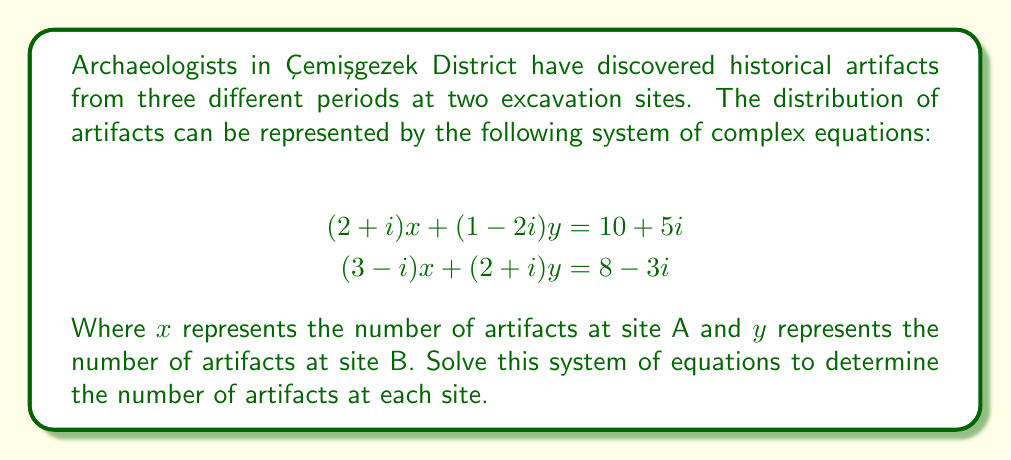Show me your answer to this math problem. To solve this system of equations with complex coefficients, we'll use the substitution method:

1) From the first equation, express $x$ in terms of $y$:
   $$(2+i)x + (1-2i)y = 10+5i$$
   $$(2+i)x = (10+5i) - (1-2i)y$$
   $$x = \frac{(10+5i) - (1-2i)y}{2+i}$$

2) Multiply both numerator and denominator by the complex conjugate of the denominator:
   $$x = \frac{((10+5i) - (1-2i)y)(2-i)}{(2+i)(2-i)}$$
   $$x = \frac{(10+5i)(2-i) - (1-2i)(2-i)y}{5}$$

3) Expand:
   $$x = \frac{(20-10i+10i+5i^2) - (2-i-4i+2i^2)y}{5}$$
   $$x = \frac{(15-5) - (2+3i)y}{5} = 2 - \frac{2+3i}{5}y$$

4) Substitute this expression for $x$ into the second equation:
   $$(3-i)(2 - \frac{2+3i}{5}y) + (2+i)y = 8-3i$$

5) Expand:
   $$(6-2i) - \frac{6+9i-2i-3i^2}{5}y + (2+i)y = 8-3i$$
   $$(6-2i) - \frac{9+7i}{5}y + (2+i)y = 8-3i$$

6) Multiply all terms by 5:
   $$(30-10i) - (9+7i)y + (10+5i)y = 40-15i$$

7) Combine like terms:
   $$(30-10i) + (1-2i)y = 40-15i$$

8) Subtract $(30-10i)$ from both sides:
   $$(1-2i)y = 10-5i$$

9) Divide both sides by $(1-2i)$, multiplying numerator and denominator by the complex conjugate:
   $$y = \frac{(10-5i)(1+2i)}{(1-2i)(1+2i)} = \frac{10+20i-5i-10i^2}{1+4i^2} = \frac{20+15i}{5} = 4+3i$$

10) Substitute this value of $y$ back into the equation for $x$:
    $$x = 2 - \frac{2+3i}{5}(4+3i) = 2 - \frac{8+6i+12i+9i^2}{5} = 2 - \frac{-1+18i}{5} = 2 + \frac{1-18i}{5}$$

Therefore, $x = 2.2 - 3.6i$ and $y = 4 + 3i$.
Answer: $x = 2.2 - 3.6i$, $y = 4 + 3i$ 